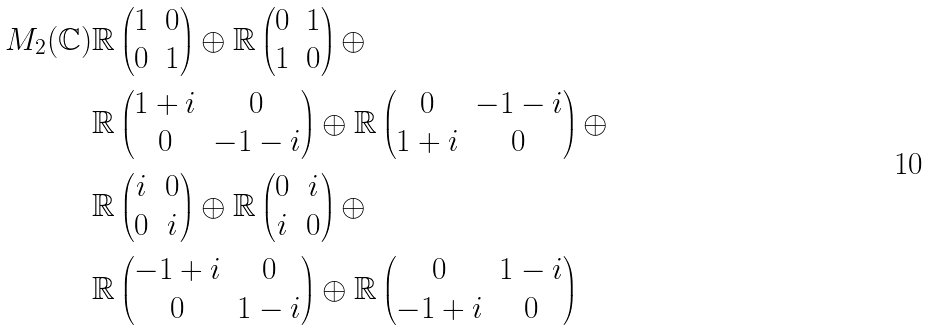<formula> <loc_0><loc_0><loc_500><loc_500>M _ { 2 } ( \mathbb { C } ) & \mathbb { R } \begin{pmatrix} 1 & 0 \\ 0 & 1 \end{pmatrix} \oplus \mathbb { R } \begin{pmatrix} 0 & 1 \\ 1 & 0 \end{pmatrix} \oplus \\ & \mathbb { R } \begin{pmatrix} 1 + i & 0 \\ 0 & - 1 - i \end{pmatrix} \oplus \mathbb { R } \begin{pmatrix} 0 & - 1 - i \\ 1 + i & 0 \end{pmatrix} \oplus \\ & \mathbb { R } \begin{pmatrix} i & 0 \\ 0 & i \end{pmatrix} \oplus \mathbb { R } \begin{pmatrix} 0 & i \\ i & 0 \end{pmatrix} \oplus \\ & \mathbb { R } \begin{pmatrix} - 1 + i & 0 \\ 0 & 1 - i \end{pmatrix} \oplus \mathbb { R } \begin{pmatrix} 0 & 1 - i \\ - 1 + i & 0 \end{pmatrix}</formula> 